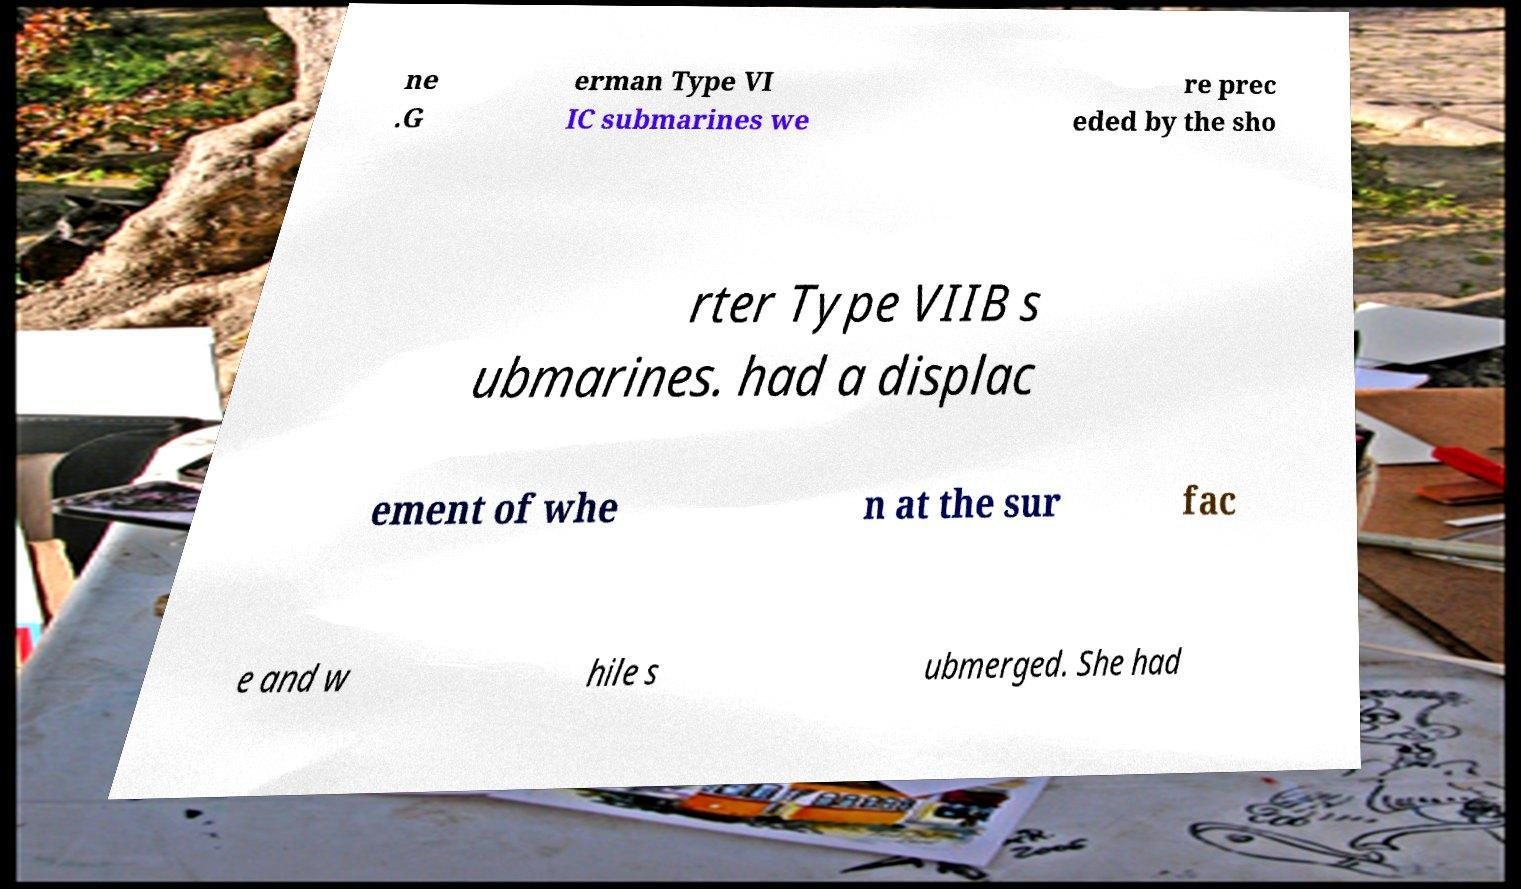There's text embedded in this image that I need extracted. Can you transcribe it verbatim? ne .G erman Type VI IC submarines we re prec eded by the sho rter Type VIIB s ubmarines. had a displac ement of whe n at the sur fac e and w hile s ubmerged. She had 